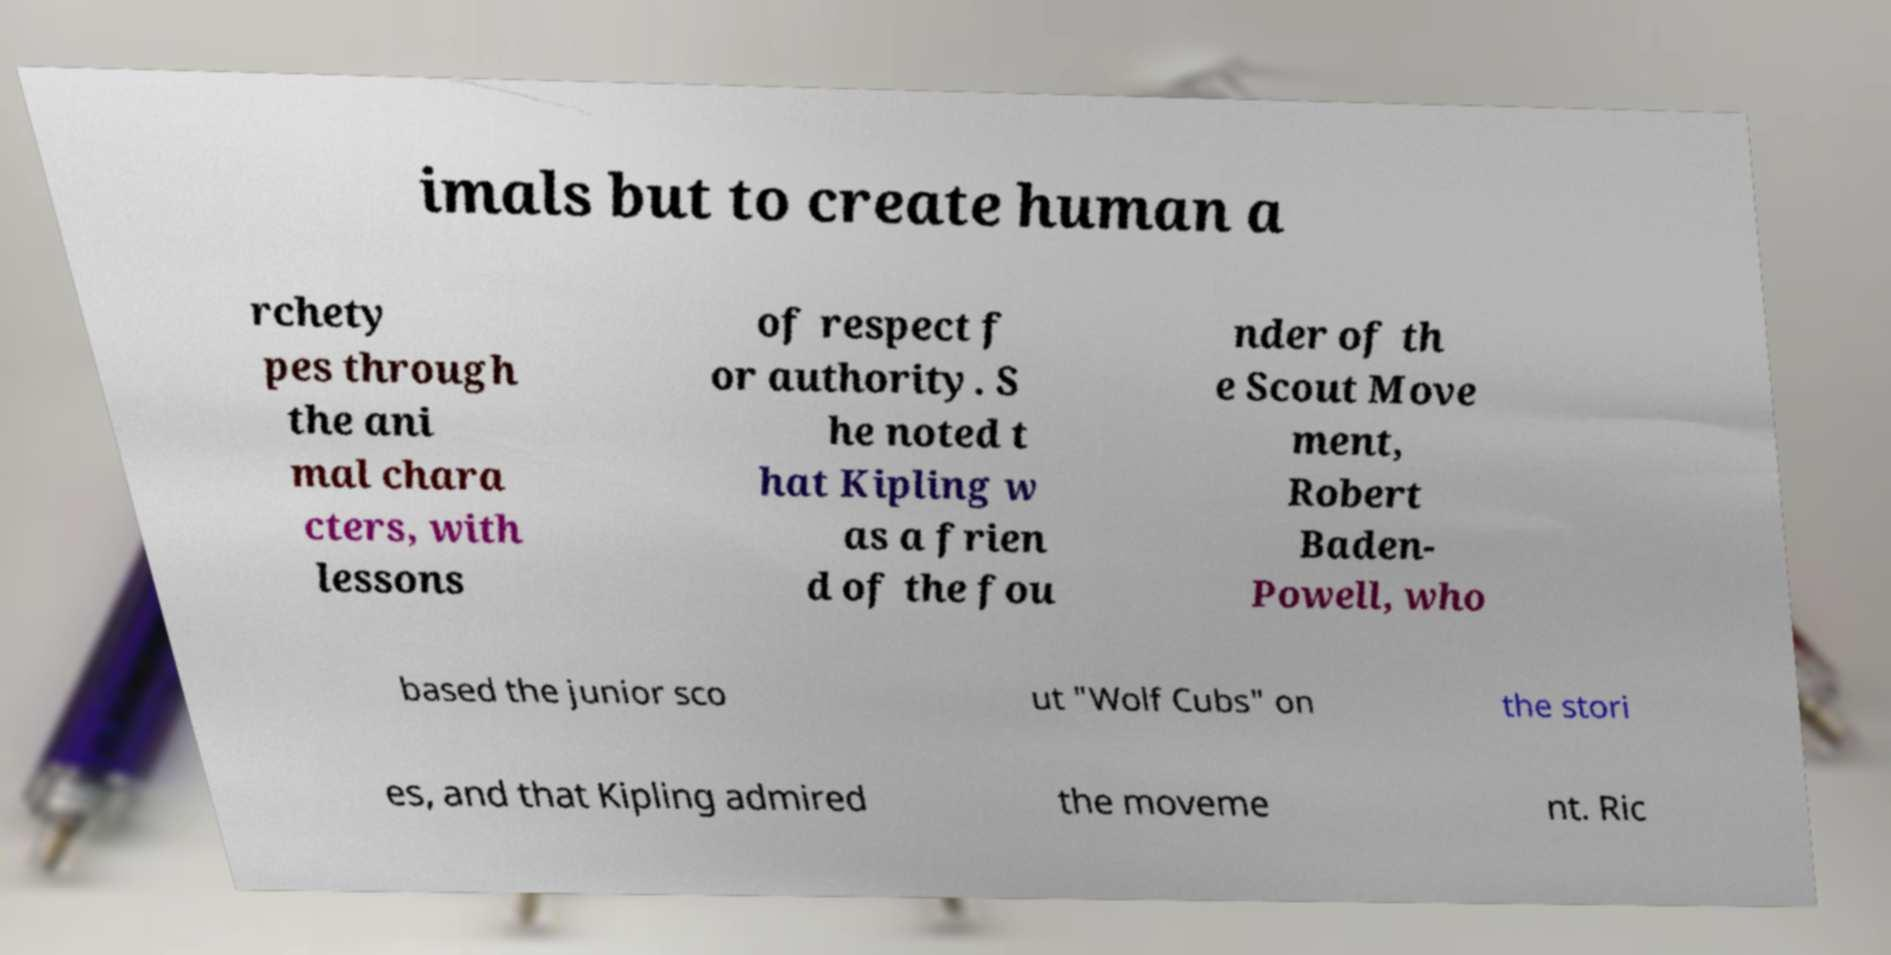Please identify and transcribe the text found in this image. imals but to create human a rchety pes through the ani mal chara cters, with lessons of respect f or authority. S he noted t hat Kipling w as a frien d of the fou nder of th e Scout Move ment, Robert Baden- Powell, who based the junior sco ut "Wolf Cubs" on the stori es, and that Kipling admired the moveme nt. Ric 